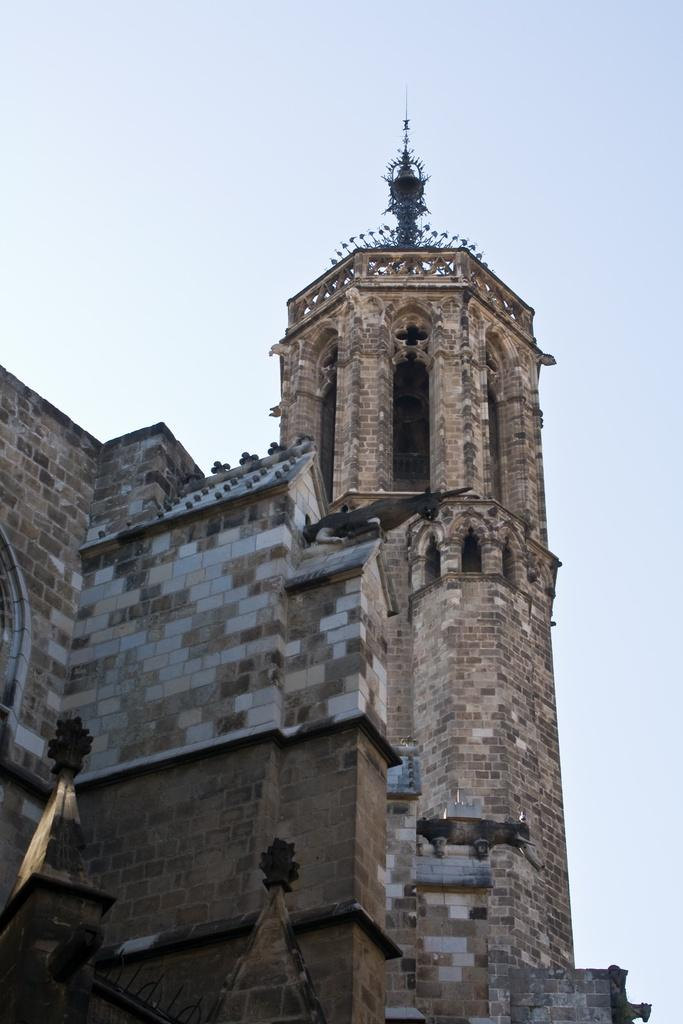What type of structure is the main subject of the image? There is a castle in the image. Where is the castle located in relation to the image? The castle is in the front of the image. What is visible at the top of the image? The sky is visible at the top of the image. Can you see the limit of the sea in the image? There is no sea present in the image, so it is not possible to see its limit. 